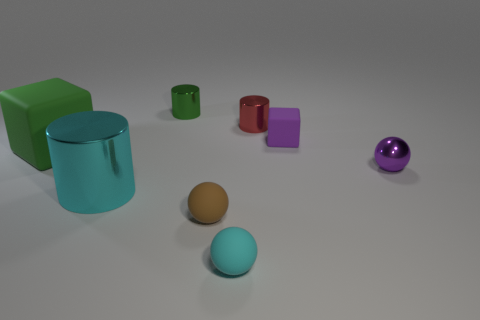There is a green shiny object that is the same shape as the cyan shiny thing; what size is it?
Your answer should be compact. Small. There is a purple thing to the left of the purple sphere; what material is it?
Give a very brief answer. Rubber. Are there fewer tiny cyan matte balls that are left of the tiny green metal cylinder than small matte things?
Keep it short and to the point. Yes. There is a matte object behind the cube on the left side of the red metallic cylinder; what shape is it?
Give a very brief answer. Cube. The large shiny thing has what color?
Provide a short and direct response. Cyan. How many other objects are the same size as the cyan cylinder?
Your answer should be very brief. 1. There is a cylinder that is both on the right side of the big cylinder and to the left of the cyan matte thing; what material is it?
Make the answer very short. Metal. There is a cyan thing that is in front of the brown sphere; is its size the same as the small red metal thing?
Offer a very short reply. Yes. Is the small matte block the same color as the tiny metal sphere?
Your answer should be very brief. Yes. How many metal objects are both behind the large cyan object and to the left of the purple cube?
Provide a succinct answer. 2. 